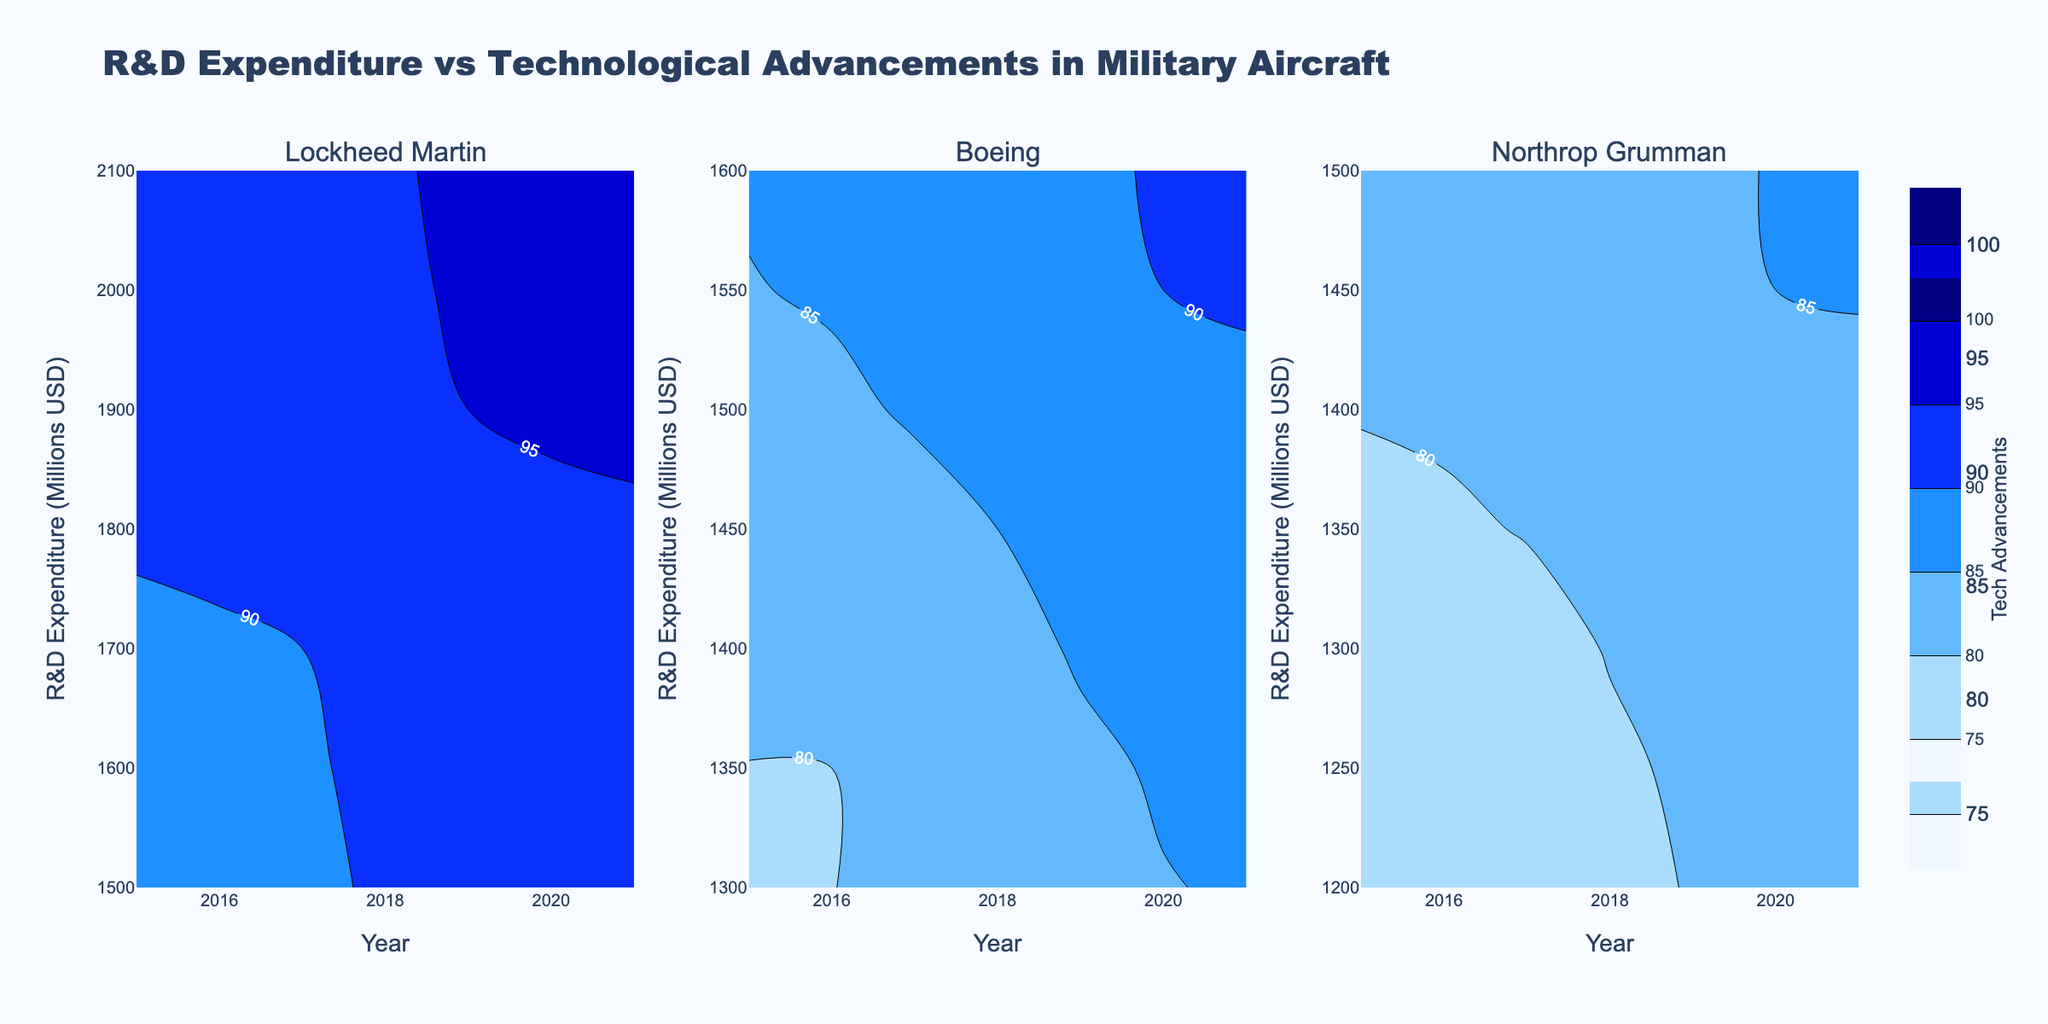what is the title of the figure? The title appears at the top of the figure and summarizes the purpose of the figure.
Answer: R&D Expenditure vs Technological Advancements in Military Aircraft What years are represented in the contour plots? The x-axis of each subplot shows the range of years included in the analysis.
Answer: 2015 to 2021 Which contractor shows the highest R&D expenditure in the year 2021? By examining the y-axis of each subplot for the year 2021, and noting the highest value on the R&D Expenditure axis, we can identify the contractor.
Answer: Lockheed Martin What's the range of Technological Advancements values shown in the color bar for Northrop Grumman? Looking at the color bar on the third subplot labeled 'Tech Advancements', you can identify the minimum and maximum values it represents.
Answer: 75 to 100 How does the R&D Expenditure of Boeing in 2018 compare to that in 2015? Find Boeing's subplot and compare the values corresponding to 2018 and 2015 on the y-axis.
Answer: It increased from 1300 to 1450 million USD For Lockheed Martin, what is the average Technological Advancements value from 2015 to 2021? Identify and sum the z-values (Technological Advancements) for each year in the Lockheed Martin subplot and then divide by the number of years (7).
Answer: (85 + 88 + 90 + 93 + 95 + 97 + 99) / 7 = ~92.43 In which year did Northrop Grumman's Technological Advancements reach 83? Look at the Northrop Grumman subplot and find the year on the x-axis where the corresponding z-value is 83.
Answer: 2019 Which contractor shows the most significant upward trend in Technological Advancements over the years? Examine the contours in each subplot and look for the subplot with the steepest gradient from left to right.
Answer: Lockheed Martin What is the increment in R&D Expenditure for Lockheed Martin from 2016 to 2017? In Lockheed Martin's subplot, find the difference in the y-values (R&D Expenditure) between 2016 and 2017.
Answer: 100 million USD Do Boeing and Northrop Grumman have similar patterns in Technological Advancements from 2015 to 2021? Compare the contours in the Boeing and Northrop Grumman subplots to see if their patterns over the years are similar.
Answer: Yes 